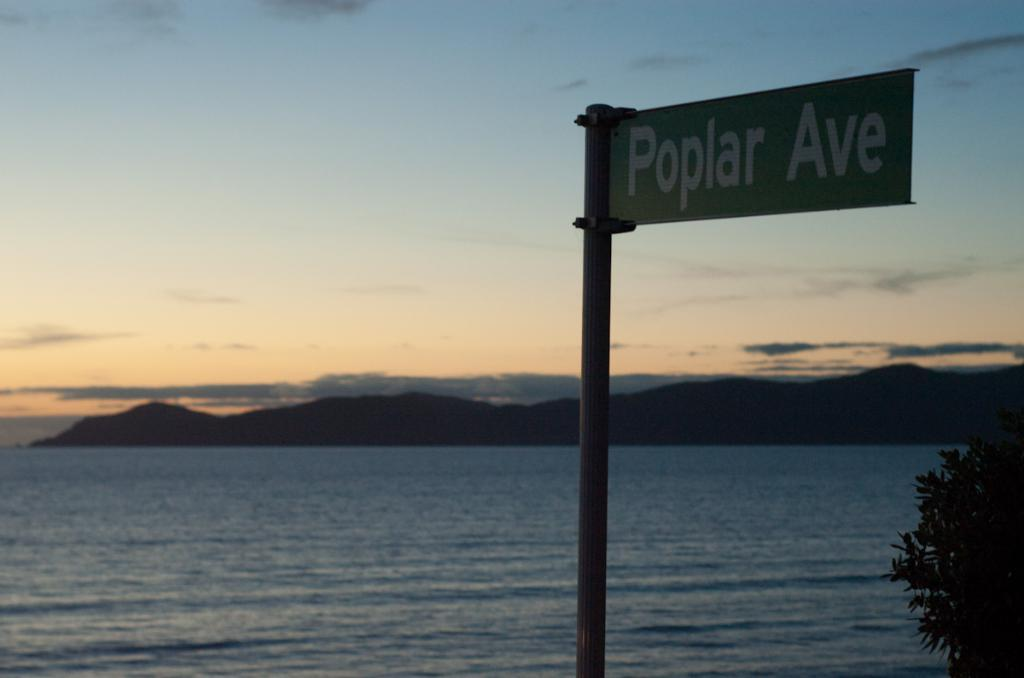What is on the pole in the image? There is a sign board on a pole in the image. What type of natural environment can be seen in the image? Trees, water, hills, and the sky are visible in the image. What is the condition of the sky in the image? Clouds are present in the sky, which is visible in the background of the image. What type of bottle is being used to create motion in the water in the image? There is no bottle or motion present in the water in the image. What type of steel structure can be seen in the image? There is no steel structure present in the image. 